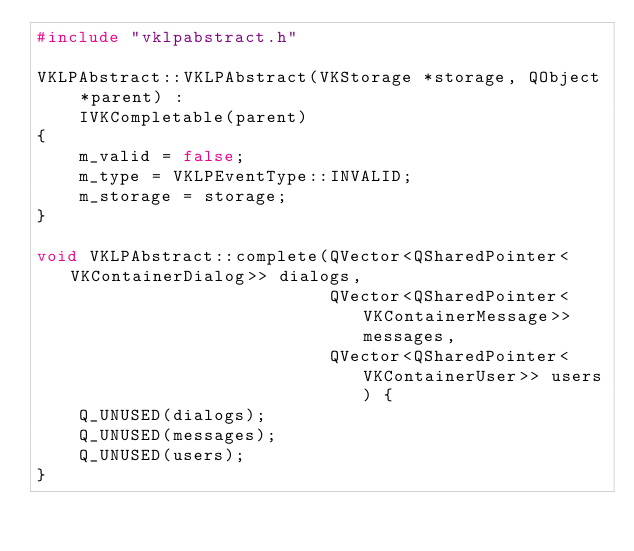<code> <loc_0><loc_0><loc_500><loc_500><_C++_>#include "vklpabstract.h"

VKLPAbstract::VKLPAbstract(VKStorage *storage, QObject *parent) :
    IVKCompletable(parent)
{
    m_valid = false;
    m_type = VKLPEventType::INVALID;
    m_storage = storage;
}

void VKLPAbstract::complete(QVector<QSharedPointer<VKContainerDialog>> dialogs,
                            QVector<QSharedPointer<VKContainerMessage>> messages,
                            QVector<QSharedPointer<VKContainerUser>> users) {
    Q_UNUSED(dialogs);
    Q_UNUSED(messages);
    Q_UNUSED(users);
}
</code> 